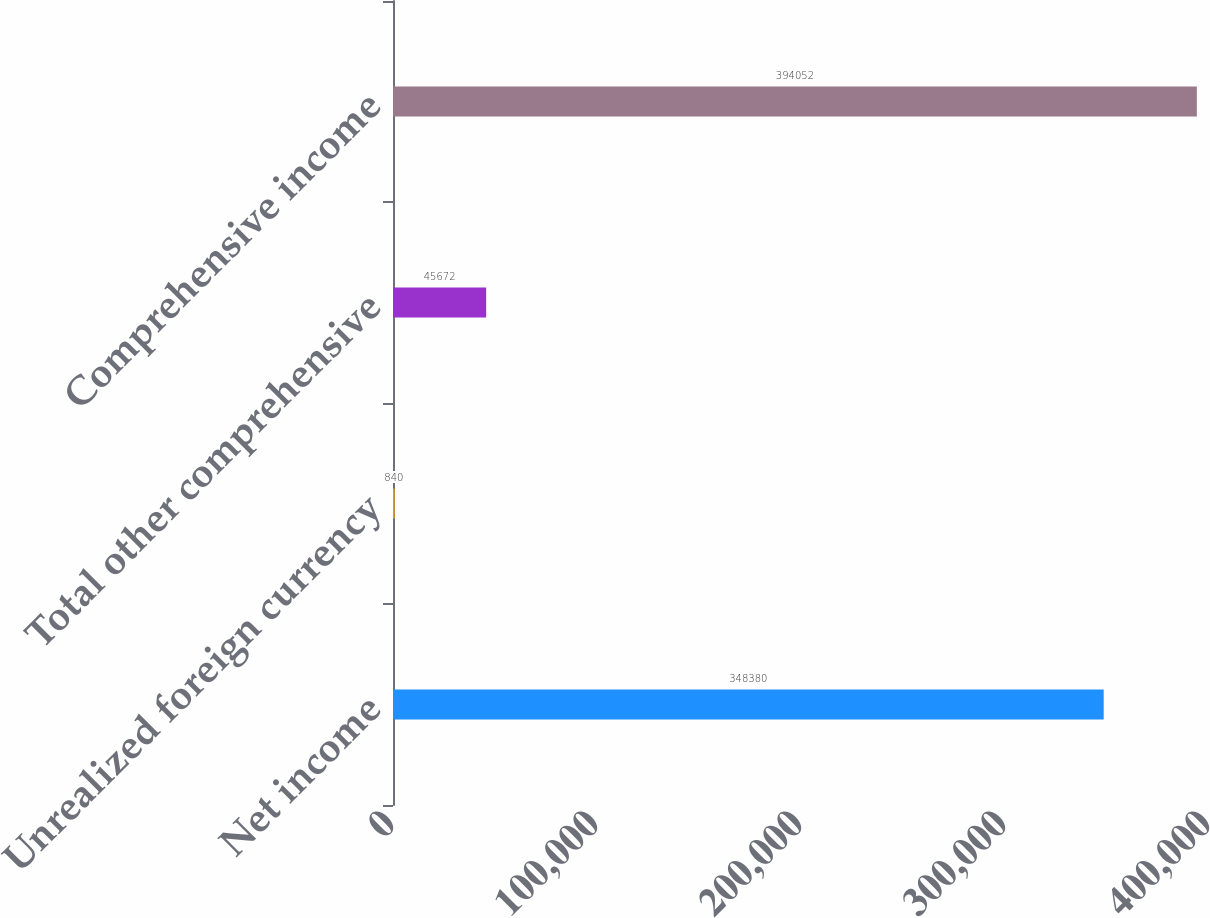Convert chart to OTSL. <chart><loc_0><loc_0><loc_500><loc_500><bar_chart><fcel>Net income<fcel>Unrealized foreign currency<fcel>Total other comprehensive<fcel>Comprehensive income<nl><fcel>348380<fcel>840<fcel>45672<fcel>394052<nl></chart> 